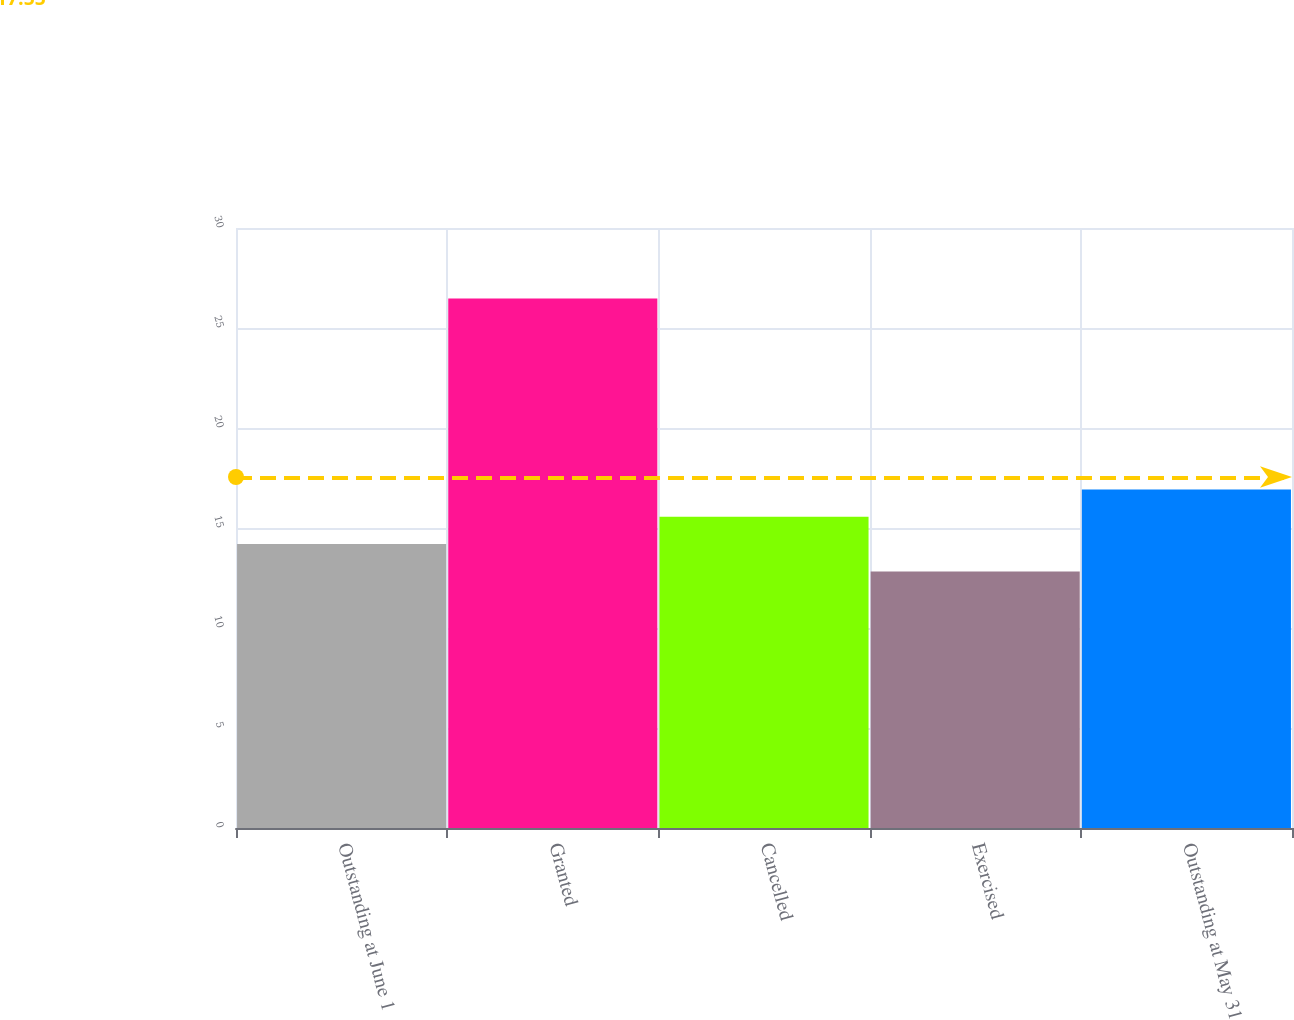<chart> <loc_0><loc_0><loc_500><loc_500><bar_chart><fcel>Outstanding at June 1<fcel>Granted<fcel>Cancelled<fcel>Exercised<fcel>Outstanding at May 31<nl><fcel>14.2<fcel>26.48<fcel>15.56<fcel>12.83<fcel>16.93<nl></chart> 